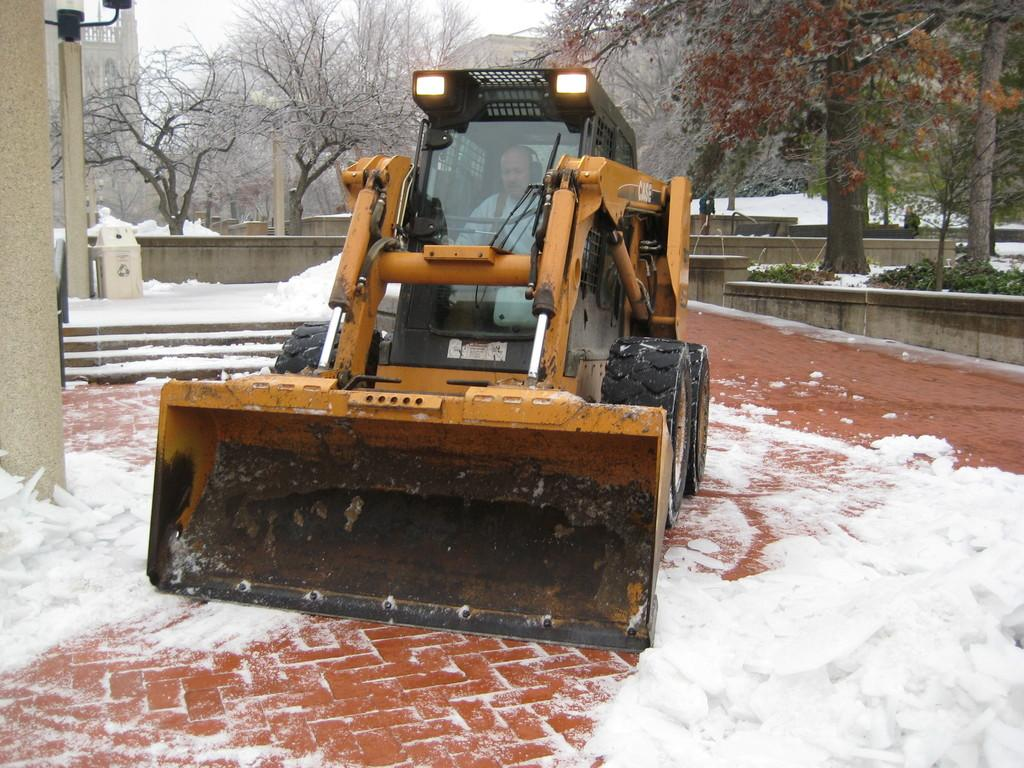What is the man in the image doing? The man is inside a vehicle. What is the weather like in the image? There is snow visible in the image. What can be seen in the background of the image? There is a wall, trees, plants, and the sky visible in the background of the image. What type of ship can be seen sailing in the background of the image? There is no ship visible in the image; it features a man inside a vehicle with a snowy background and a wall, trees, plants, and sky in the background. 